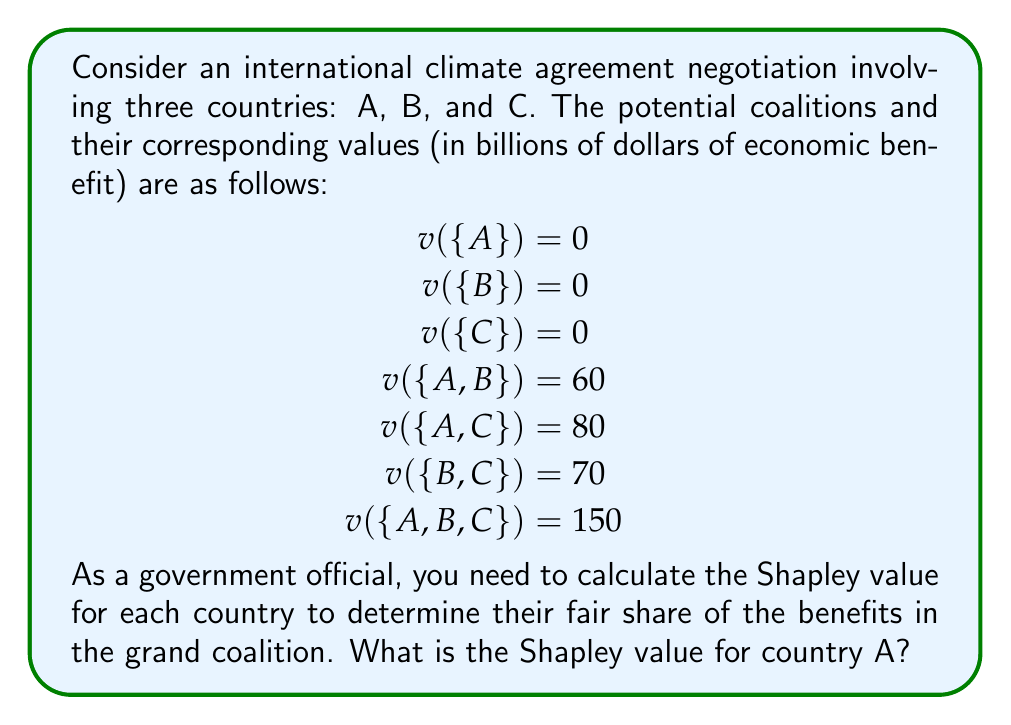Solve this math problem. To calculate the Shapley value for country A, we need to follow these steps:

1. List all possible orderings of the countries:
   (A,B,C), (A,C,B), (B,A,C), (B,C,A), (C,A,B), (C,B,A)

2. For each ordering, calculate A's marginal contribution:

   (A,B,C): $v(\{A\}) - v(\{\}) = 0$
   (A,C,B): $v(\{A\}) - v(\{\}) = 0$
   (B,A,C): $v(\{A,B\}) - v(\{B\}) = 60 - 0 = 60$
   (B,C,A): $v(\{A,B,C\}) - v(\{B,C\}) = 150 - 70 = 80$
   (C,A,B): $v(\{A,C\}) - v(\{C\}) = 80 - 0 = 80$
   (C,B,A): $v(\{A,B,C\}) - v(\{B,C\}) = 150 - 70 = 80$

3. Calculate the average of these marginal contributions:

   $$ \phi_A = \frac{1}{6}(0 + 0 + 60 + 80 + 80 + 80) = \frac{300}{6} = 50 $$

Therefore, the Shapley value for country A is 50 billion dollars.
Answer: $50 billion 